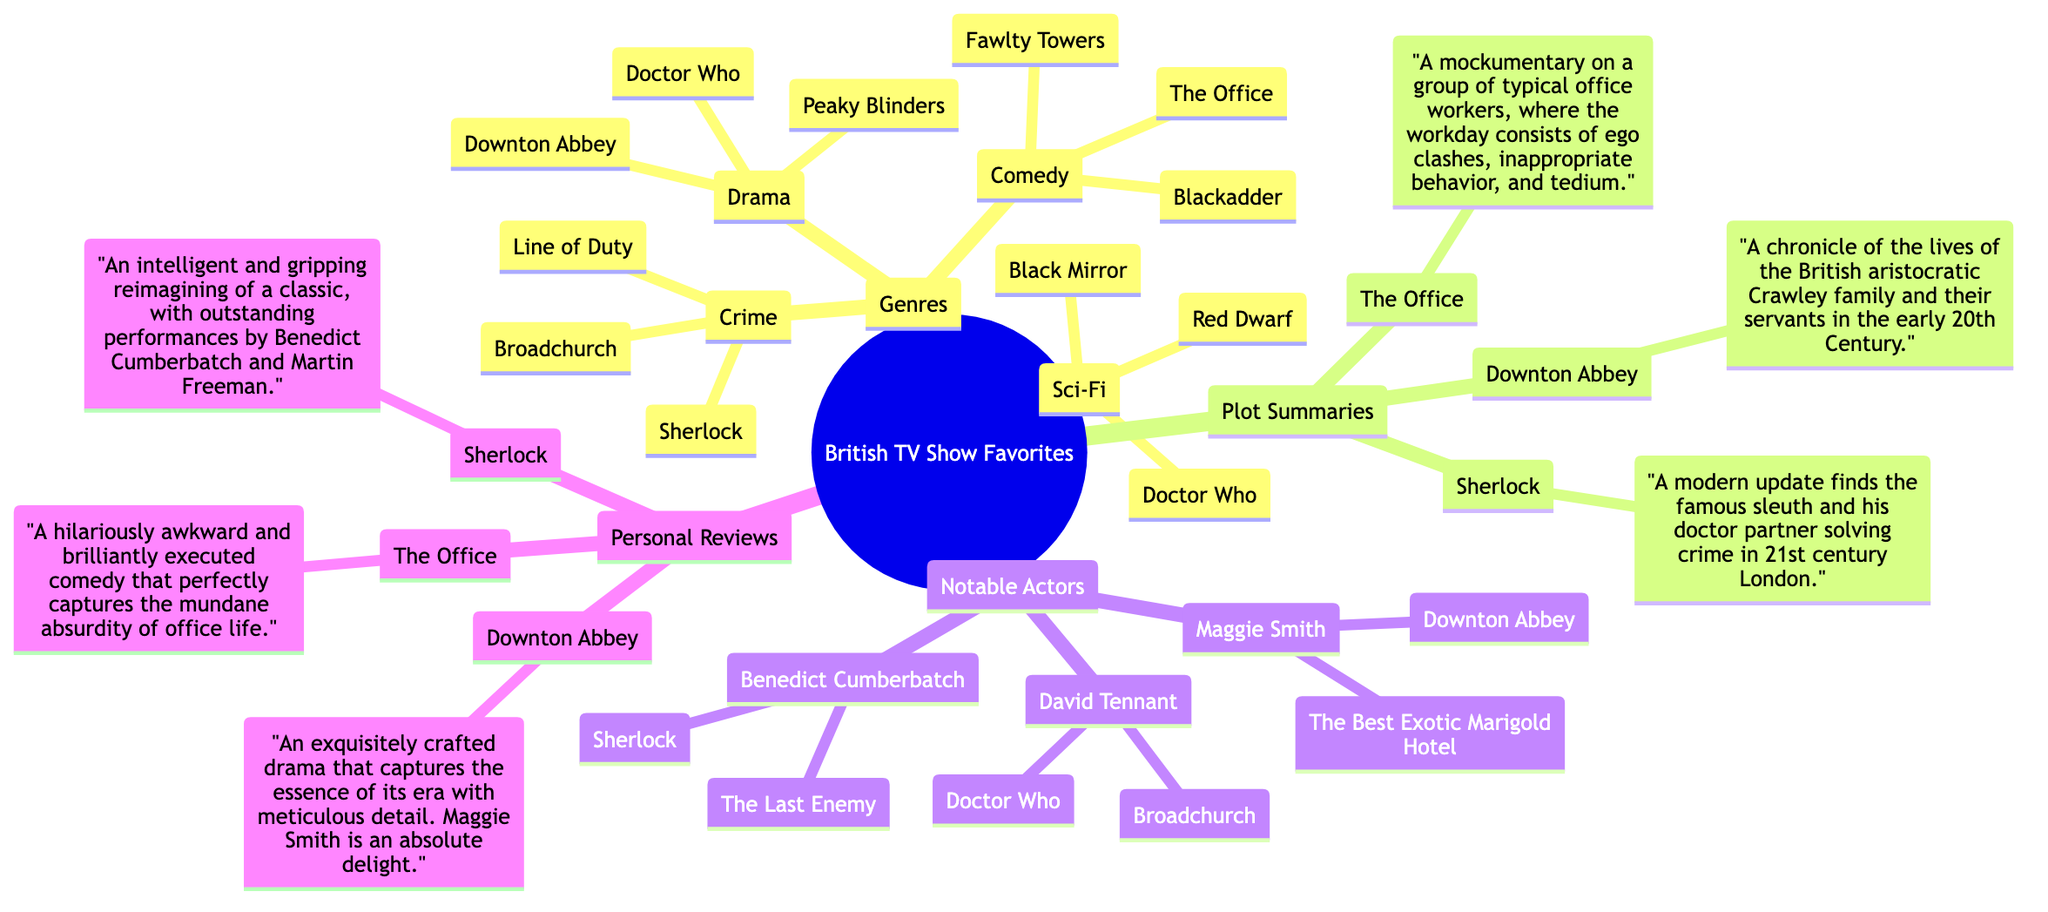What are the genres listed in the mind map? The mind map has a node for "Genres" which branches into four categories: Drama, Comedy, Crime, and Sci-Fi. These genres can be seen directly listed under the "Genres" node.
Answer: Drama, Comedy, Crime, Sci-Fi How many shows are listed under the Comedy genre? By counting the shows listed under the "Comedy" branch of the "Genres" node, we find that there are three shows: The Office, Fawlty Towers, and Blackadder.
Answer: 3 Which actor has played roles in "Doctor Who" and "Broadchurch"? Looking under "Notable Actors," we see that David Tennant is listed with both "Doctor Who" and "Broadchurch." This indicates his involvement in both shows.
Answer: David Tennant What is the plot summary of "Sherlock"? The mind map includes a "Plot Summaries" node, which contains a specific summary for "Sherlock," detailing it as a modern update of Sherlock Holmes solving crimes in 21st century London.
Answer: A modern update finds the famous sleuth and his doctor partner solving crime in 21st century London Which show has a notable review mentioning Maggie Smith? Under "Personal Reviews," "Downton Abbey" has a review that includes a comment about Maggie Smith's performance, indicating her significant role in that show.
Answer: Downton Abbey What is the main theme of "The Office"? In the "Plot Summaries" section, the theme of "The Office" is described as a mockumentary focused on the everyday lives of office workers, illustrating their challenges and interactions.
Answer: A mockumentary on a group of typical office workers.. Which genres include "Doctor Who"? The mind map shows that "Doctor Who" is categorized both under the "Drama" and the "Sci-Fi" genres, highlighting its dual appeal.
Answer: Drama, Sci-Fi How many notable actors are mentioned in connection with "Sherlock"? The "Notable Actors" section shows that there is one notable actor specifically linked to "Sherlock," which is Benedict Cumberbatch.
Answer: 1 What is the common theme of the shows in the Crime genre? By examining the shows listed under the "Crime" genre, they are all centered around solving crimes and investigations, which forms a common theme of mystery and inquiry.
Answer: Solving crimes and investigations 